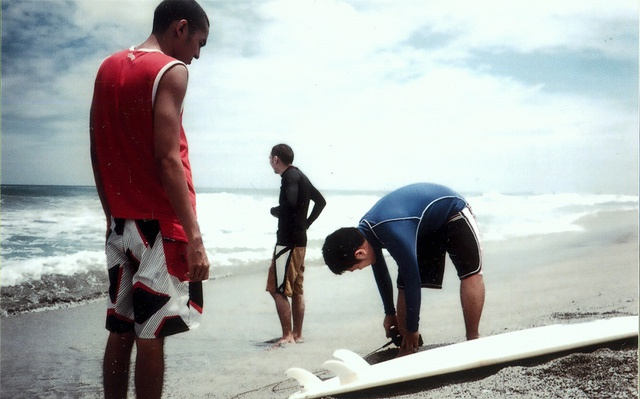Describe the objects in this image and their specific colors. I can see people in darkgray, black, maroon, and gray tones, people in darkgray, black, maroon, gray, and blue tones, surfboard in darkgray, ivory, lightgray, and black tones, and people in darkgray, black, maroon, lightgray, and gray tones in this image. 